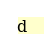<code> <loc_0><loc_0><loc_500><loc_500><_Python_>d</code> 